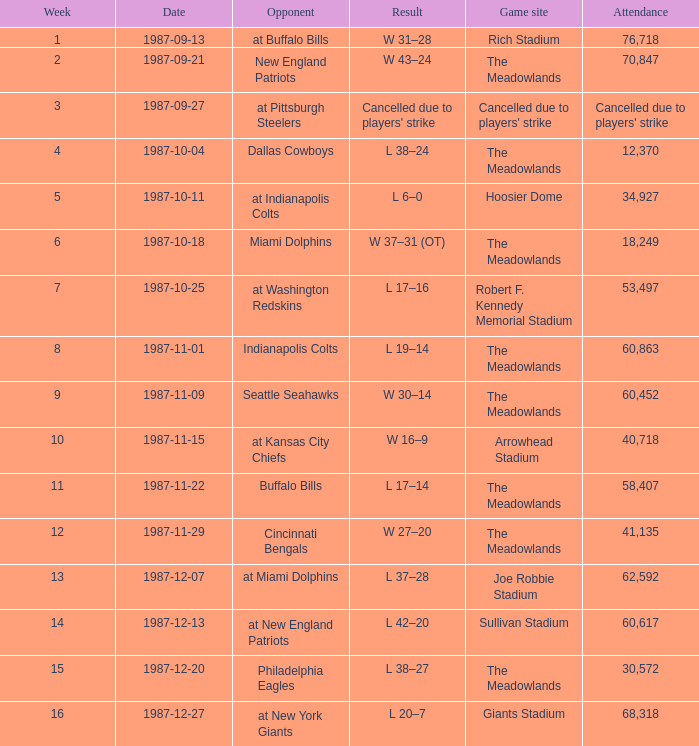In the game following week 15, which team did the jets compete against? At new york giants. 